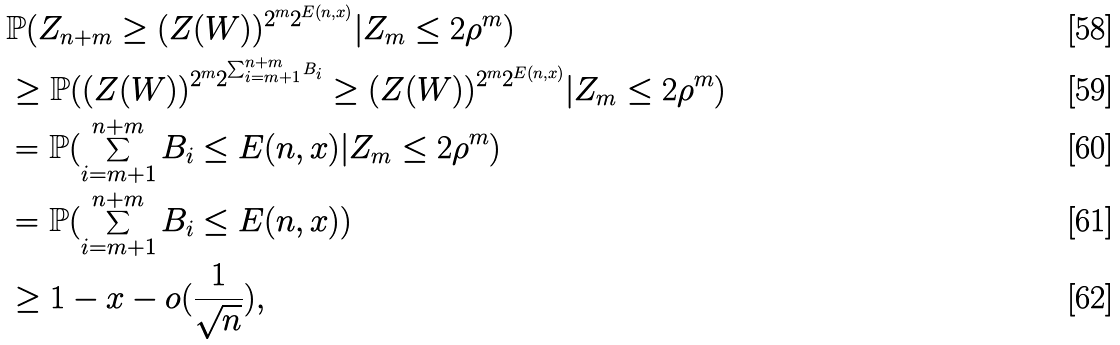<formula> <loc_0><loc_0><loc_500><loc_500>& \mathbb { P } ( Z _ { n + m } \geq ( Z ( W ) ) ^ { 2 ^ { m } 2 ^ { E ( n , x ) } } | Z _ { m } \leq 2 { \rho } ^ { m } ) \\ & \geq \mathbb { P } ( ( Z ( W ) ) ^ { 2 ^ { m } 2 ^ { \sum _ { i = m + 1 } ^ { n + m } B _ { i } } } \geq ( Z ( W ) ) ^ { 2 ^ { m } 2 ^ { E ( n , x ) } } | Z _ { m } \leq 2 { \rho } ^ { m } ) \\ & = \mathbb { P } ( \sum _ { i = m + 1 } ^ { n + m } B _ { i } \leq E ( n , x ) | Z _ { m } \leq 2 { \rho } ^ { m } ) \\ & = \mathbb { P } ( \sum _ { i = m + 1 } ^ { n + m } B _ { i } \leq E ( n , x ) ) \\ & \geq 1 - x - o ( \frac { 1 } { \sqrt { n } } ) ,</formula> 